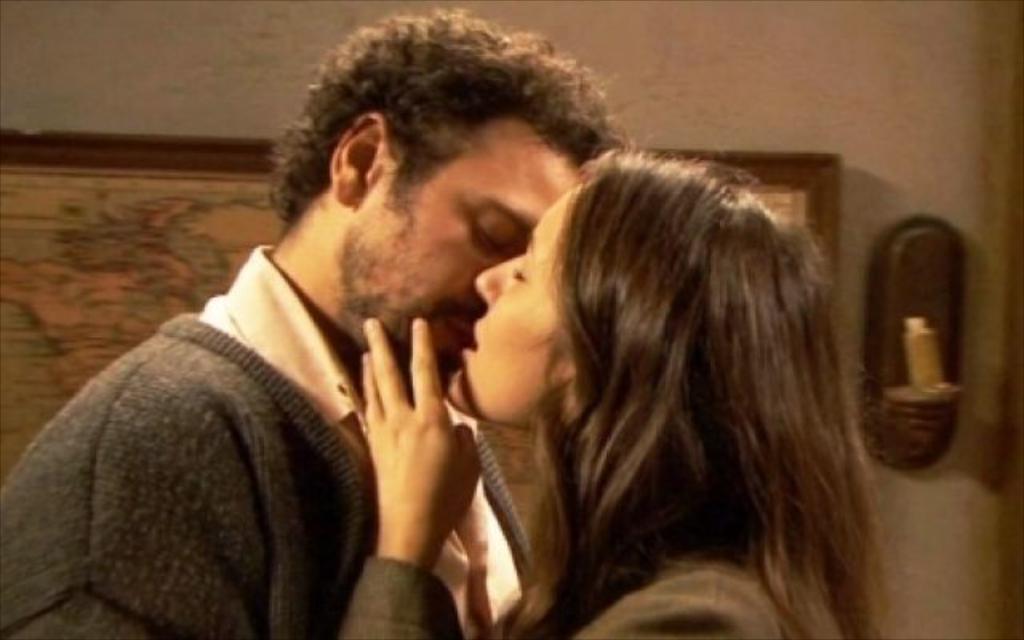In one or two sentences, can you explain what this image depicts? In this image there is a person and a girl kissing each other, behind them there is a frame hanging on the wall, beside the frame there is an object. 